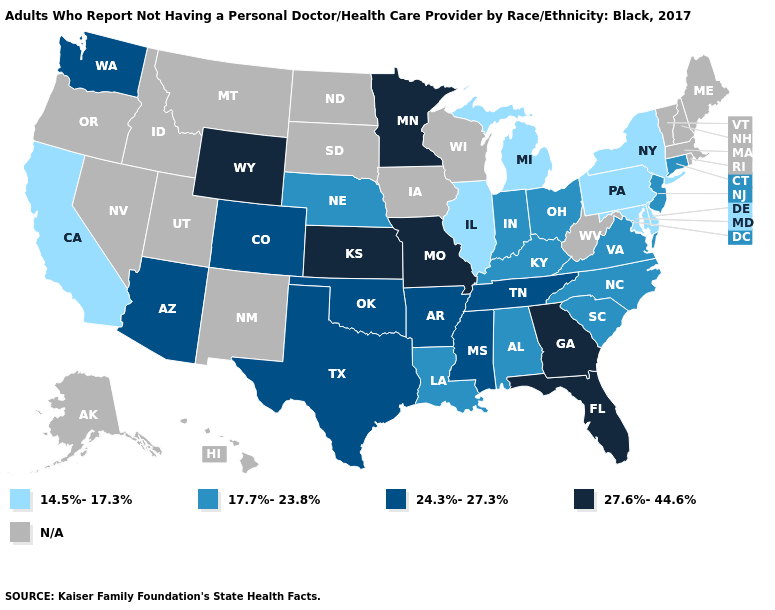What is the lowest value in the USA?
Give a very brief answer. 14.5%-17.3%. Among the states that border Kentucky , does Illinois have the lowest value?
Keep it brief. Yes. What is the highest value in the USA?
Be succinct. 27.6%-44.6%. Which states have the lowest value in the USA?
Short answer required. California, Delaware, Illinois, Maryland, Michigan, New York, Pennsylvania. Among the states that border Oregon , which have the highest value?
Give a very brief answer. Washington. What is the value of Washington?
Concise answer only. 24.3%-27.3%. Does the map have missing data?
Keep it brief. Yes. What is the value of Wyoming?
Quick response, please. 27.6%-44.6%. What is the lowest value in states that border Rhode Island?
Answer briefly. 17.7%-23.8%. Which states have the highest value in the USA?
Give a very brief answer. Florida, Georgia, Kansas, Minnesota, Missouri, Wyoming. What is the value of North Carolina?
Answer briefly. 17.7%-23.8%. What is the value of New Jersey?
Give a very brief answer. 17.7%-23.8%. Does Kansas have the lowest value in the USA?
Give a very brief answer. No. 